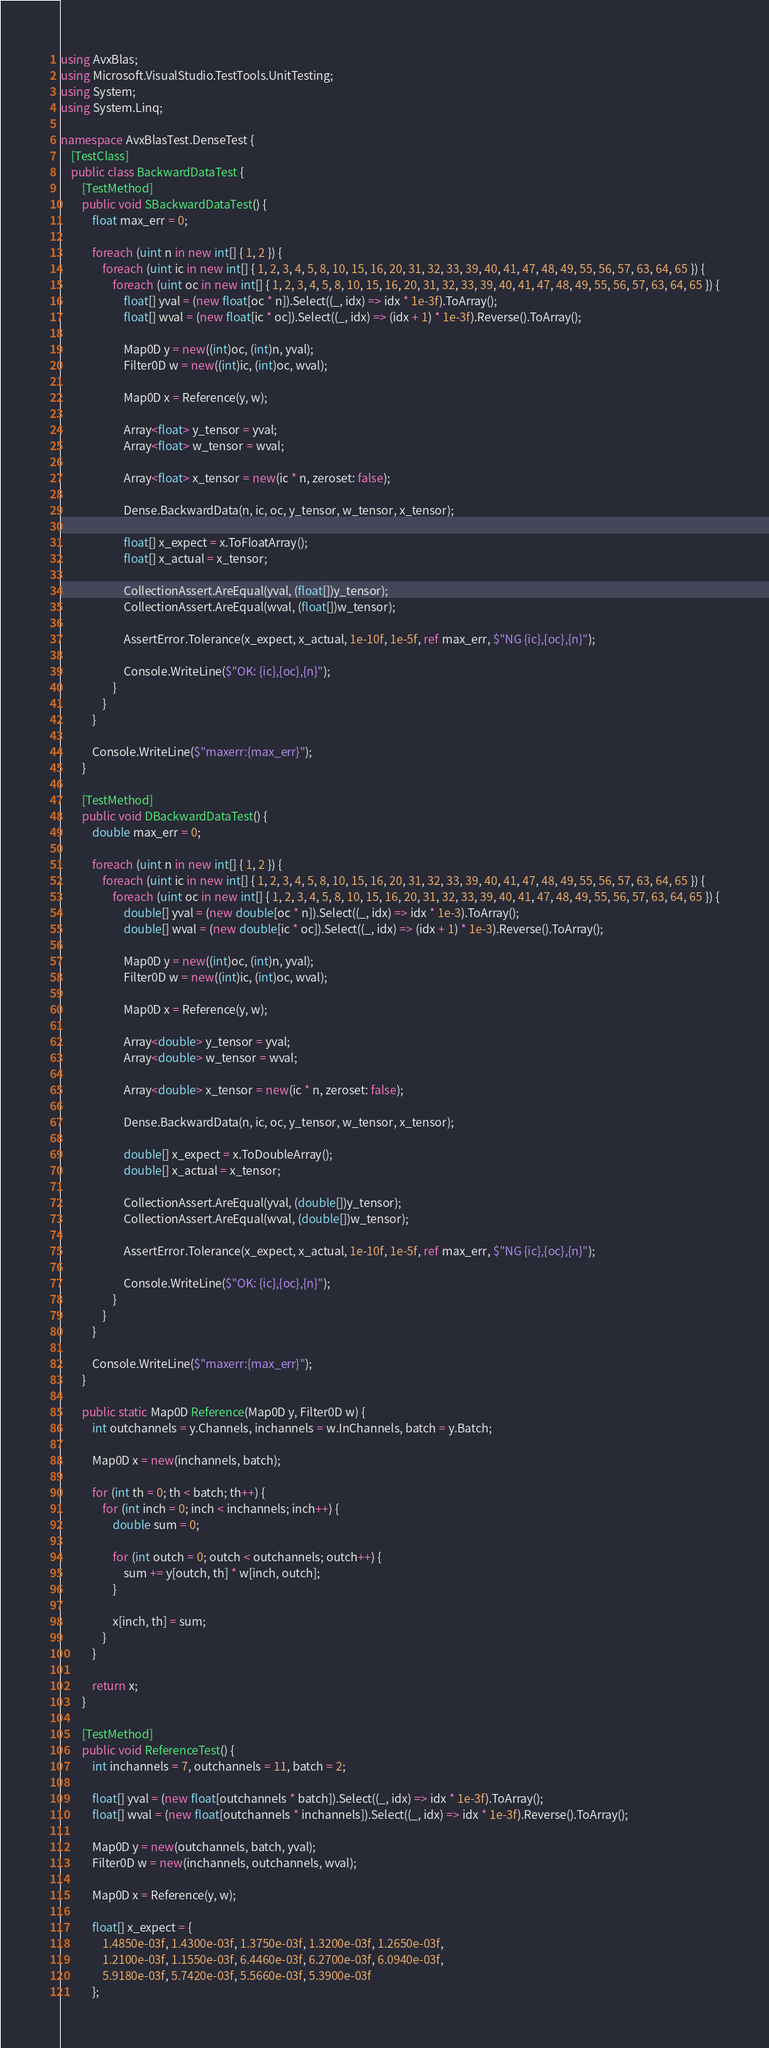Convert code to text. <code><loc_0><loc_0><loc_500><loc_500><_C#_>using AvxBlas;
using Microsoft.VisualStudio.TestTools.UnitTesting;
using System;
using System.Linq;

namespace AvxBlasTest.DenseTest {
    [TestClass]
    public class BackwardDataTest {
        [TestMethod]
        public void SBackwardDataTest() {
            float max_err = 0;

            foreach (uint n in new int[] { 1, 2 }) {
                foreach (uint ic in new int[] { 1, 2, 3, 4, 5, 8, 10, 15, 16, 20, 31, 32, 33, 39, 40, 41, 47, 48, 49, 55, 56, 57, 63, 64, 65 }) {
                    foreach (uint oc in new int[] { 1, 2, 3, 4, 5, 8, 10, 15, 16, 20, 31, 32, 33, 39, 40, 41, 47, 48, 49, 55, 56, 57, 63, 64, 65 }) {
                        float[] yval = (new float[oc * n]).Select((_, idx) => idx * 1e-3f).ToArray();
                        float[] wval = (new float[ic * oc]).Select((_, idx) => (idx + 1) * 1e-3f).Reverse().ToArray();

                        Map0D y = new((int)oc, (int)n, yval);
                        Filter0D w = new((int)ic, (int)oc, wval);

                        Map0D x = Reference(y, w);

                        Array<float> y_tensor = yval;
                        Array<float> w_tensor = wval;

                        Array<float> x_tensor = new(ic * n, zeroset: false);

                        Dense.BackwardData(n, ic, oc, y_tensor, w_tensor, x_tensor);

                        float[] x_expect = x.ToFloatArray();
                        float[] x_actual = x_tensor;

                        CollectionAssert.AreEqual(yval, (float[])y_tensor);
                        CollectionAssert.AreEqual(wval, (float[])w_tensor);

                        AssertError.Tolerance(x_expect, x_actual, 1e-10f, 1e-5f, ref max_err, $"NG {ic},{oc},{n}");

                        Console.WriteLine($"OK: {ic},{oc},{n}");
                    }
                }
            }

            Console.WriteLine($"maxerr:{max_err}");
        }

        [TestMethod]
        public void DBackwardDataTest() {
            double max_err = 0;

            foreach (uint n in new int[] { 1, 2 }) {
                foreach (uint ic in new int[] { 1, 2, 3, 4, 5, 8, 10, 15, 16, 20, 31, 32, 33, 39, 40, 41, 47, 48, 49, 55, 56, 57, 63, 64, 65 }) {
                    foreach (uint oc in new int[] { 1, 2, 3, 4, 5, 8, 10, 15, 16, 20, 31, 32, 33, 39, 40, 41, 47, 48, 49, 55, 56, 57, 63, 64, 65 }) {
                        double[] yval = (new double[oc * n]).Select((_, idx) => idx * 1e-3).ToArray();
                        double[] wval = (new double[ic * oc]).Select((_, idx) => (idx + 1) * 1e-3).Reverse().ToArray();

                        Map0D y = new((int)oc, (int)n, yval);
                        Filter0D w = new((int)ic, (int)oc, wval);

                        Map0D x = Reference(y, w);

                        Array<double> y_tensor = yval;
                        Array<double> w_tensor = wval;

                        Array<double> x_tensor = new(ic * n, zeroset: false);

                        Dense.BackwardData(n, ic, oc, y_tensor, w_tensor, x_tensor);

                        double[] x_expect = x.ToDoubleArray();
                        double[] x_actual = x_tensor;

                        CollectionAssert.AreEqual(yval, (double[])y_tensor);
                        CollectionAssert.AreEqual(wval, (double[])w_tensor);

                        AssertError.Tolerance(x_expect, x_actual, 1e-10f, 1e-5f, ref max_err, $"NG {ic},{oc},{n}");

                        Console.WriteLine($"OK: {ic},{oc},{n}");
                    }
                }
            }

            Console.WriteLine($"maxerr:{max_err}");
        }

        public static Map0D Reference(Map0D y, Filter0D w) {
            int outchannels = y.Channels, inchannels = w.InChannels, batch = y.Batch;

            Map0D x = new(inchannels, batch);

            for (int th = 0; th < batch; th++) {
                for (int inch = 0; inch < inchannels; inch++) {
                    double sum = 0;

                    for (int outch = 0; outch < outchannels; outch++) {
                        sum += y[outch, th] * w[inch, outch];
                    }

                    x[inch, th] = sum;
                }
            }

            return x;
        }

        [TestMethod]
        public void ReferenceTest() {
            int inchannels = 7, outchannels = 11, batch = 2;

            float[] yval = (new float[outchannels * batch]).Select((_, idx) => idx * 1e-3f).ToArray();
            float[] wval = (new float[outchannels * inchannels]).Select((_, idx) => idx * 1e-3f).Reverse().ToArray();

            Map0D y = new(outchannels, batch, yval);
            Filter0D w = new(inchannels, outchannels, wval);

            Map0D x = Reference(y, w);

            float[] x_expect = {
                1.4850e-03f, 1.4300e-03f, 1.3750e-03f, 1.3200e-03f, 1.2650e-03f,
                1.2100e-03f, 1.1550e-03f, 6.4460e-03f, 6.2700e-03f, 6.0940e-03f,
                5.9180e-03f, 5.7420e-03f, 5.5660e-03f, 5.3900e-03f
            };
</code> 